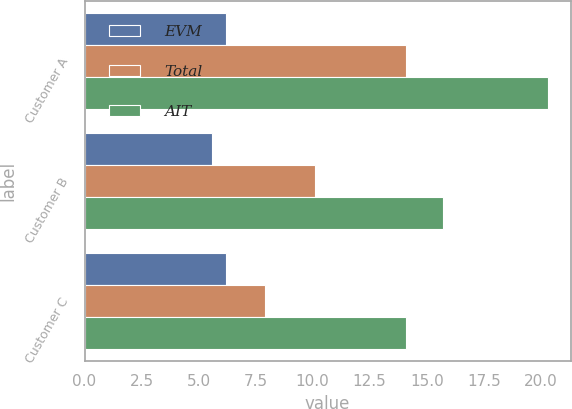Convert chart. <chart><loc_0><loc_0><loc_500><loc_500><stacked_bar_chart><ecel><fcel>Customer A<fcel>Customer B<fcel>Customer C<nl><fcel>EVM<fcel>6.2<fcel>5.6<fcel>6.2<nl><fcel>Total<fcel>14.1<fcel>10.1<fcel>7.9<nl><fcel>AIT<fcel>20.3<fcel>15.7<fcel>14.1<nl></chart> 